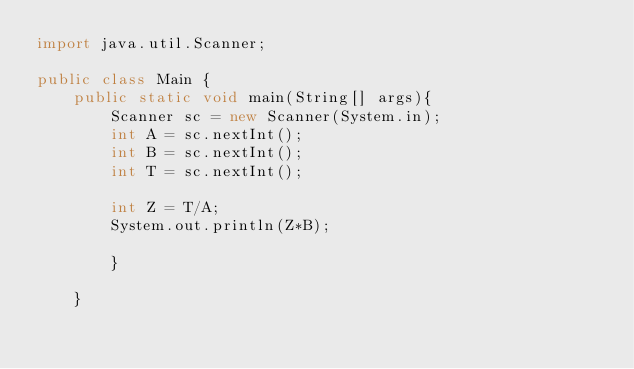Convert code to text. <code><loc_0><loc_0><loc_500><loc_500><_Java_>import java.util.Scanner;

public class Main {
    public static void main(String[] args){
        Scanner sc = new Scanner(System.in);
        int A = sc.nextInt();
        int B = sc.nextInt();
        int T = sc.nextInt();

        int Z = T/A;
        System.out.println(Z*B);

        }

    }</code> 